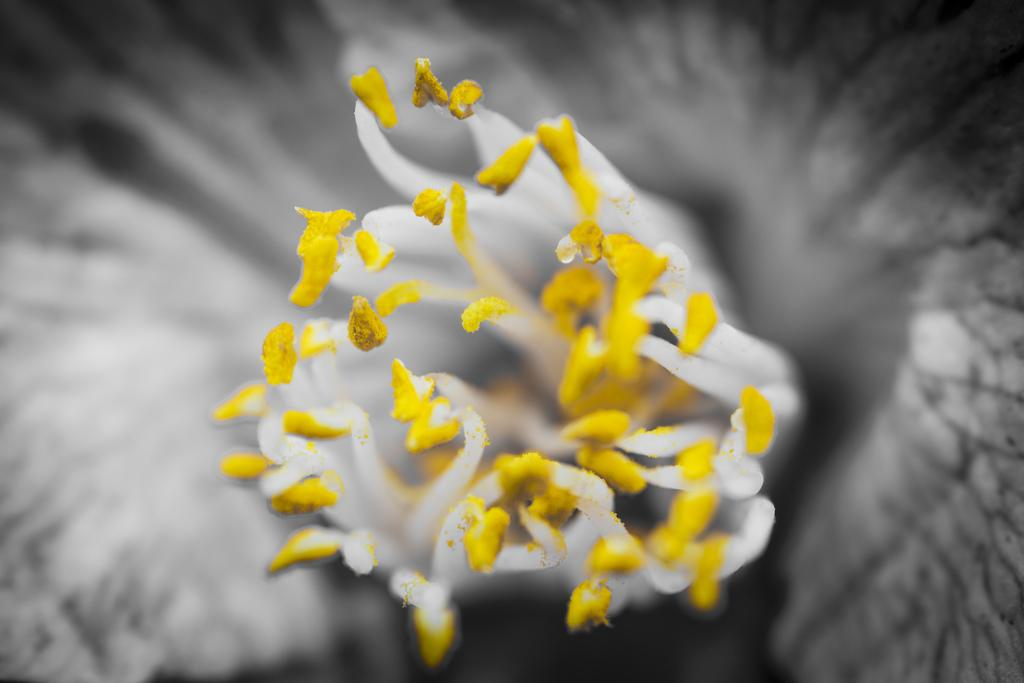What types of flowers can be seen in the image? There are white flowers and yellow flowers in the image. What type of plot is being used for the quilt in the image? There is no quilt or plot present in the image; it features white and yellow flowers. 